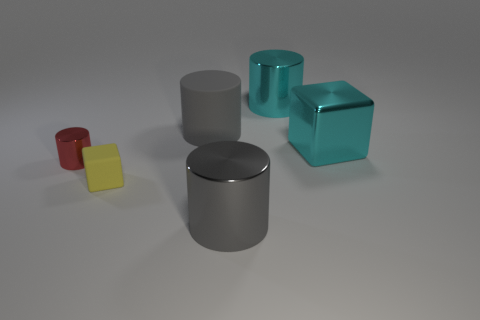Subtract all cyan metal cylinders. How many cylinders are left? 3 Add 4 purple cylinders. How many objects exist? 10 Subtract 3 cylinders. How many cylinders are left? 1 Subtract all red cylinders. How many cylinders are left? 3 Subtract all cylinders. How many objects are left? 2 Subtract all brown blocks. How many gray cylinders are left? 2 Add 1 matte cylinders. How many matte cylinders exist? 2 Subtract 2 gray cylinders. How many objects are left? 4 Subtract all yellow cylinders. Subtract all brown cubes. How many cylinders are left? 4 Subtract all cyan things. Subtract all yellow things. How many objects are left? 3 